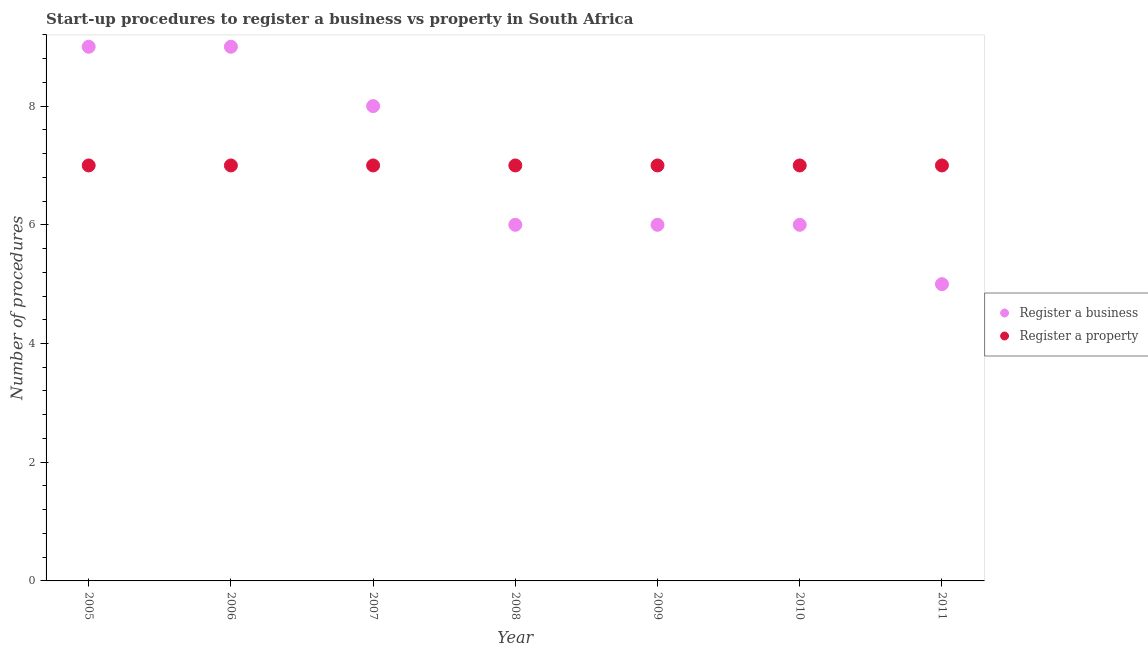How many different coloured dotlines are there?
Your answer should be compact. 2. What is the number of procedures to register a business in 2007?
Offer a very short reply. 8. Across all years, what is the maximum number of procedures to register a business?
Your answer should be very brief. 9. Across all years, what is the minimum number of procedures to register a business?
Your answer should be compact. 5. In which year was the number of procedures to register a business maximum?
Ensure brevity in your answer.  2005. What is the total number of procedures to register a business in the graph?
Your answer should be compact. 49. What is the difference between the number of procedures to register a business in 2006 and the number of procedures to register a property in 2005?
Provide a succinct answer. 2. What is the average number of procedures to register a property per year?
Make the answer very short. 7. In the year 2010, what is the difference between the number of procedures to register a business and number of procedures to register a property?
Offer a very short reply. -1. In how many years, is the number of procedures to register a property greater than 6.8?
Provide a short and direct response. 7. What is the ratio of the number of procedures to register a property in 2005 to that in 2009?
Your response must be concise. 1. Is the number of procedures to register a property in 2006 less than that in 2010?
Your response must be concise. No. What is the difference between the highest and the second highest number of procedures to register a property?
Ensure brevity in your answer.  0. What is the difference between the highest and the lowest number of procedures to register a property?
Keep it short and to the point. 0. In how many years, is the number of procedures to register a business greater than the average number of procedures to register a business taken over all years?
Your response must be concise. 3. Is the sum of the number of procedures to register a property in 2008 and 2010 greater than the maximum number of procedures to register a business across all years?
Your answer should be compact. Yes. Does the number of procedures to register a business monotonically increase over the years?
Give a very brief answer. No. Is the number of procedures to register a property strictly greater than the number of procedures to register a business over the years?
Ensure brevity in your answer.  No. How many dotlines are there?
Provide a succinct answer. 2. How many years are there in the graph?
Keep it short and to the point. 7. What is the difference between two consecutive major ticks on the Y-axis?
Your response must be concise. 2. Are the values on the major ticks of Y-axis written in scientific E-notation?
Ensure brevity in your answer.  No. Does the graph contain grids?
Keep it short and to the point. No. Where does the legend appear in the graph?
Offer a very short reply. Center right. How are the legend labels stacked?
Give a very brief answer. Vertical. What is the title of the graph?
Provide a short and direct response. Start-up procedures to register a business vs property in South Africa. Does "Subsidies" appear as one of the legend labels in the graph?
Make the answer very short. No. What is the label or title of the Y-axis?
Offer a very short reply. Number of procedures. What is the Number of procedures of Register a business in 2005?
Offer a terse response. 9. What is the Number of procedures in Register a property in 2005?
Your answer should be compact. 7. What is the Number of procedures in Register a business in 2006?
Your answer should be compact. 9. What is the Number of procedures in Register a property in 2007?
Make the answer very short. 7. What is the Number of procedures in Register a business in 2009?
Give a very brief answer. 6. What is the Number of procedures in Register a business in 2010?
Offer a terse response. 6. What is the Number of procedures of Register a property in 2011?
Offer a terse response. 7. Across all years, what is the maximum Number of procedures of Register a property?
Provide a short and direct response. 7. Across all years, what is the minimum Number of procedures in Register a property?
Ensure brevity in your answer.  7. What is the total Number of procedures of Register a business in the graph?
Give a very brief answer. 49. What is the difference between the Number of procedures in Register a business in 2005 and that in 2006?
Your answer should be very brief. 0. What is the difference between the Number of procedures of Register a property in 2005 and that in 2006?
Offer a very short reply. 0. What is the difference between the Number of procedures of Register a business in 2005 and that in 2007?
Your response must be concise. 1. What is the difference between the Number of procedures in Register a property in 2005 and that in 2008?
Ensure brevity in your answer.  0. What is the difference between the Number of procedures in Register a business in 2005 and that in 2010?
Offer a very short reply. 3. What is the difference between the Number of procedures in Register a property in 2005 and that in 2010?
Your answer should be very brief. 0. What is the difference between the Number of procedures in Register a business in 2005 and that in 2011?
Ensure brevity in your answer.  4. What is the difference between the Number of procedures of Register a business in 2006 and that in 2009?
Provide a succinct answer. 3. What is the difference between the Number of procedures of Register a property in 2006 and that in 2009?
Your answer should be very brief. 0. What is the difference between the Number of procedures of Register a property in 2006 and that in 2010?
Provide a short and direct response. 0. What is the difference between the Number of procedures of Register a business in 2006 and that in 2011?
Your response must be concise. 4. What is the difference between the Number of procedures of Register a property in 2006 and that in 2011?
Ensure brevity in your answer.  0. What is the difference between the Number of procedures of Register a business in 2007 and that in 2008?
Your answer should be compact. 2. What is the difference between the Number of procedures of Register a business in 2007 and that in 2009?
Offer a very short reply. 2. What is the difference between the Number of procedures of Register a property in 2007 and that in 2009?
Your response must be concise. 0. What is the difference between the Number of procedures in Register a property in 2007 and that in 2010?
Provide a short and direct response. 0. What is the difference between the Number of procedures in Register a property in 2007 and that in 2011?
Offer a terse response. 0. What is the difference between the Number of procedures of Register a business in 2008 and that in 2009?
Keep it short and to the point. 0. What is the difference between the Number of procedures of Register a property in 2008 and that in 2009?
Your answer should be compact. 0. What is the difference between the Number of procedures in Register a business in 2009 and that in 2010?
Your response must be concise. 0. What is the difference between the Number of procedures in Register a property in 2009 and that in 2011?
Your response must be concise. 0. What is the difference between the Number of procedures of Register a property in 2010 and that in 2011?
Your answer should be very brief. 0. What is the difference between the Number of procedures of Register a business in 2005 and the Number of procedures of Register a property in 2006?
Provide a short and direct response. 2. What is the difference between the Number of procedures in Register a business in 2005 and the Number of procedures in Register a property in 2008?
Ensure brevity in your answer.  2. What is the difference between the Number of procedures in Register a business in 2005 and the Number of procedures in Register a property in 2009?
Your answer should be compact. 2. What is the difference between the Number of procedures of Register a business in 2005 and the Number of procedures of Register a property in 2010?
Your answer should be very brief. 2. What is the difference between the Number of procedures in Register a business in 2006 and the Number of procedures in Register a property in 2008?
Offer a very short reply. 2. What is the difference between the Number of procedures of Register a business in 2006 and the Number of procedures of Register a property in 2009?
Make the answer very short. 2. What is the difference between the Number of procedures of Register a business in 2006 and the Number of procedures of Register a property in 2010?
Your answer should be compact. 2. What is the difference between the Number of procedures in Register a business in 2006 and the Number of procedures in Register a property in 2011?
Your response must be concise. 2. What is the difference between the Number of procedures of Register a business in 2007 and the Number of procedures of Register a property in 2008?
Offer a very short reply. 1. What is the difference between the Number of procedures in Register a business in 2007 and the Number of procedures in Register a property in 2009?
Your answer should be very brief. 1. What is the difference between the Number of procedures of Register a business in 2007 and the Number of procedures of Register a property in 2010?
Give a very brief answer. 1. What is the difference between the Number of procedures of Register a business in 2008 and the Number of procedures of Register a property in 2009?
Provide a succinct answer. -1. What is the difference between the Number of procedures of Register a business in 2008 and the Number of procedures of Register a property in 2010?
Your response must be concise. -1. What is the difference between the Number of procedures in Register a business in 2008 and the Number of procedures in Register a property in 2011?
Make the answer very short. -1. What is the difference between the Number of procedures in Register a business in 2009 and the Number of procedures in Register a property in 2010?
Offer a terse response. -1. What is the difference between the Number of procedures of Register a business in 2009 and the Number of procedures of Register a property in 2011?
Give a very brief answer. -1. What is the average Number of procedures in Register a business per year?
Keep it short and to the point. 7. What is the average Number of procedures of Register a property per year?
Offer a terse response. 7. In the year 2006, what is the difference between the Number of procedures of Register a business and Number of procedures of Register a property?
Ensure brevity in your answer.  2. In the year 2008, what is the difference between the Number of procedures of Register a business and Number of procedures of Register a property?
Your answer should be very brief. -1. In the year 2011, what is the difference between the Number of procedures of Register a business and Number of procedures of Register a property?
Give a very brief answer. -2. What is the ratio of the Number of procedures of Register a property in 2005 to that in 2006?
Keep it short and to the point. 1. What is the ratio of the Number of procedures of Register a business in 2005 to that in 2007?
Ensure brevity in your answer.  1.12. What is the ratio of the Number of procedures in Register a property in 2005 to that in 2007?
Offer a very short reply. 1. What is the ratio of the Number of procedures in Register a business in 2005 to that in 2009?
Ensure brevity in your answer.  1.5. What is the ratio of the Number of procedures of Register a business in 2005 to that in 2010?
Your answer should be compact. 1.5. What is the ratio of the Number of procedures in Register a property in 2005 to that in 2010?
Your answer should be very brief. 1. What is the ratio of the Number of procedures in Register a business in 2005 to that in 2011?
Offer a terse response. 1.8. What is the ratio of the Number of procedures in Register a business in 2006 to that in 2007?
Offer a very short reply. 1.12. What is the ratio of the Number of procedures of Register a business in 2006 to that in 2008?
Your answer should be compact. 1.5. What is the ratio of the Number of procedures in Register a business in 2006 to that in 2010?
Provide a short and direct response. 1.5. What is the ratio of the Number of procedures in Register a business in 2006 to that in 2011?
Provide a short and direct response. 1.8. What is the ratio of the Number of procedures of Register a property in 2007 to that in 2008?
Your response must be concise. 1. What is the ratio of the Number of procedures of Register a property in 2007 to that in 2011?
Your answer should be compact. 1. What is the ratio of the Number of procedures in Register a business in 2008 to that in 2009?
Your answer should be very brief. 1. What is the ratio of the Number of procedures in Register a property in 2008 to that in 2009?
Provide a succinct answer. 1. What is the ratio of the Number of procedures of Register a business in 2008 to that in 2010?
Keep it short and to the point. 1. What is the ratio of the Number of procedures of Register a business in 2008 to that in 2011?
Your answer should be very brief. 1.2. What is the ratio of the Number of procedures in Register a property in 2008 to that in 2011?
Your answer should be compact. 1. What is the ratio of the Number of procedures in Register a property in 2009 to that in 2010?
Offer a terse response. 1. What is the ratio of the Number of procedures of Register a business in 2009 to that in 2011?
Keep it short and to the point. 1.2. What is the ratio of the Number of procedures in Register a business in 2010 to that in 2011?
Offer a terse response. 1.2. What is the difference between the highest and the second highest Number of procedures in Register a property?
Offer a terse response. 0. What is the difference between the highest and the lowest Number of procedures of Register a business?
Ensure brevity in your answer.  4. What is the difference between the highest and the lowest Number of procedures in Register a property?
Offer a very short reply. 0. 